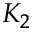<formula> <loc_0><loc_0><loc_500><loc_500>K _ { 2 }</formula> 